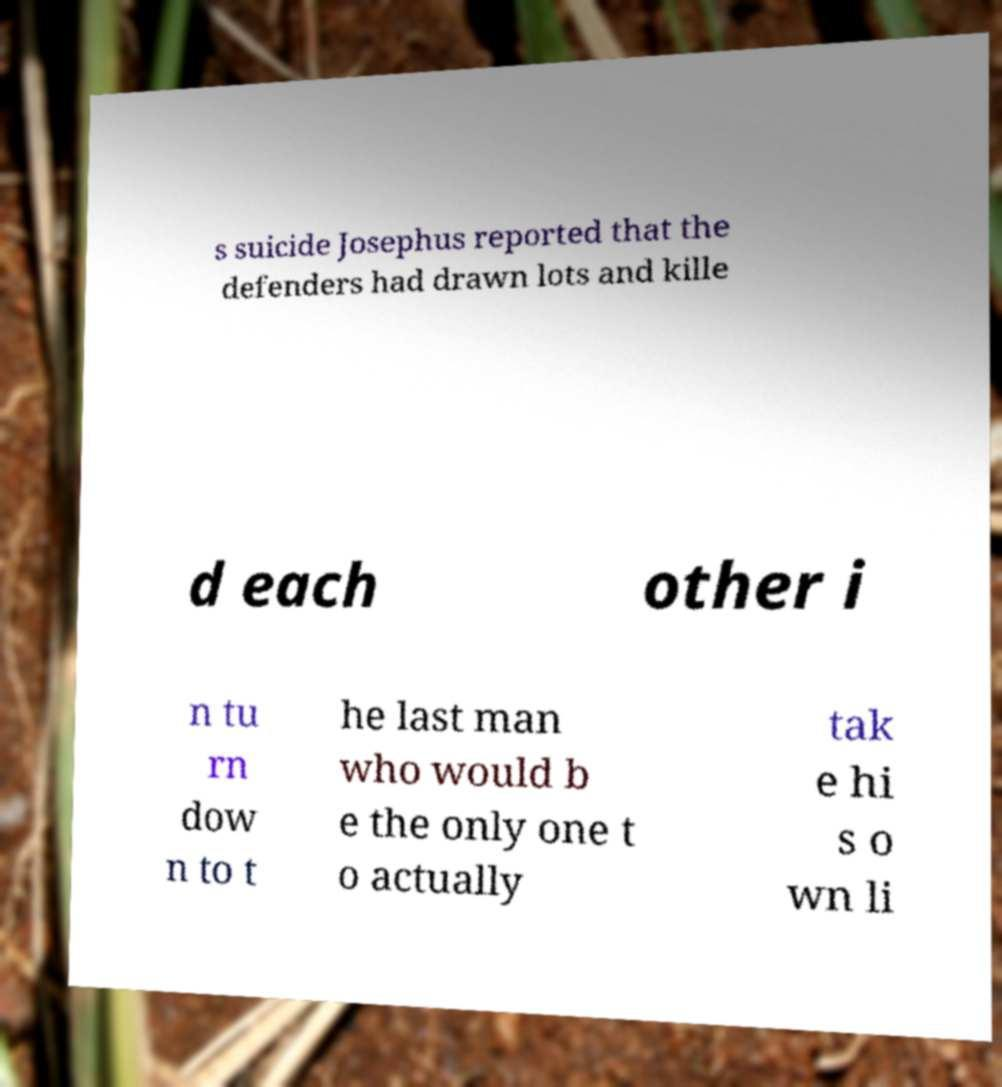I need the written content from this picture converted into text. Can you do that? s suicide Josephus reported that the defenders had drawn lots and kille d each other i n tu rn dow n to t he last man who would b e the only one t o actually tak e hi s o wn li 